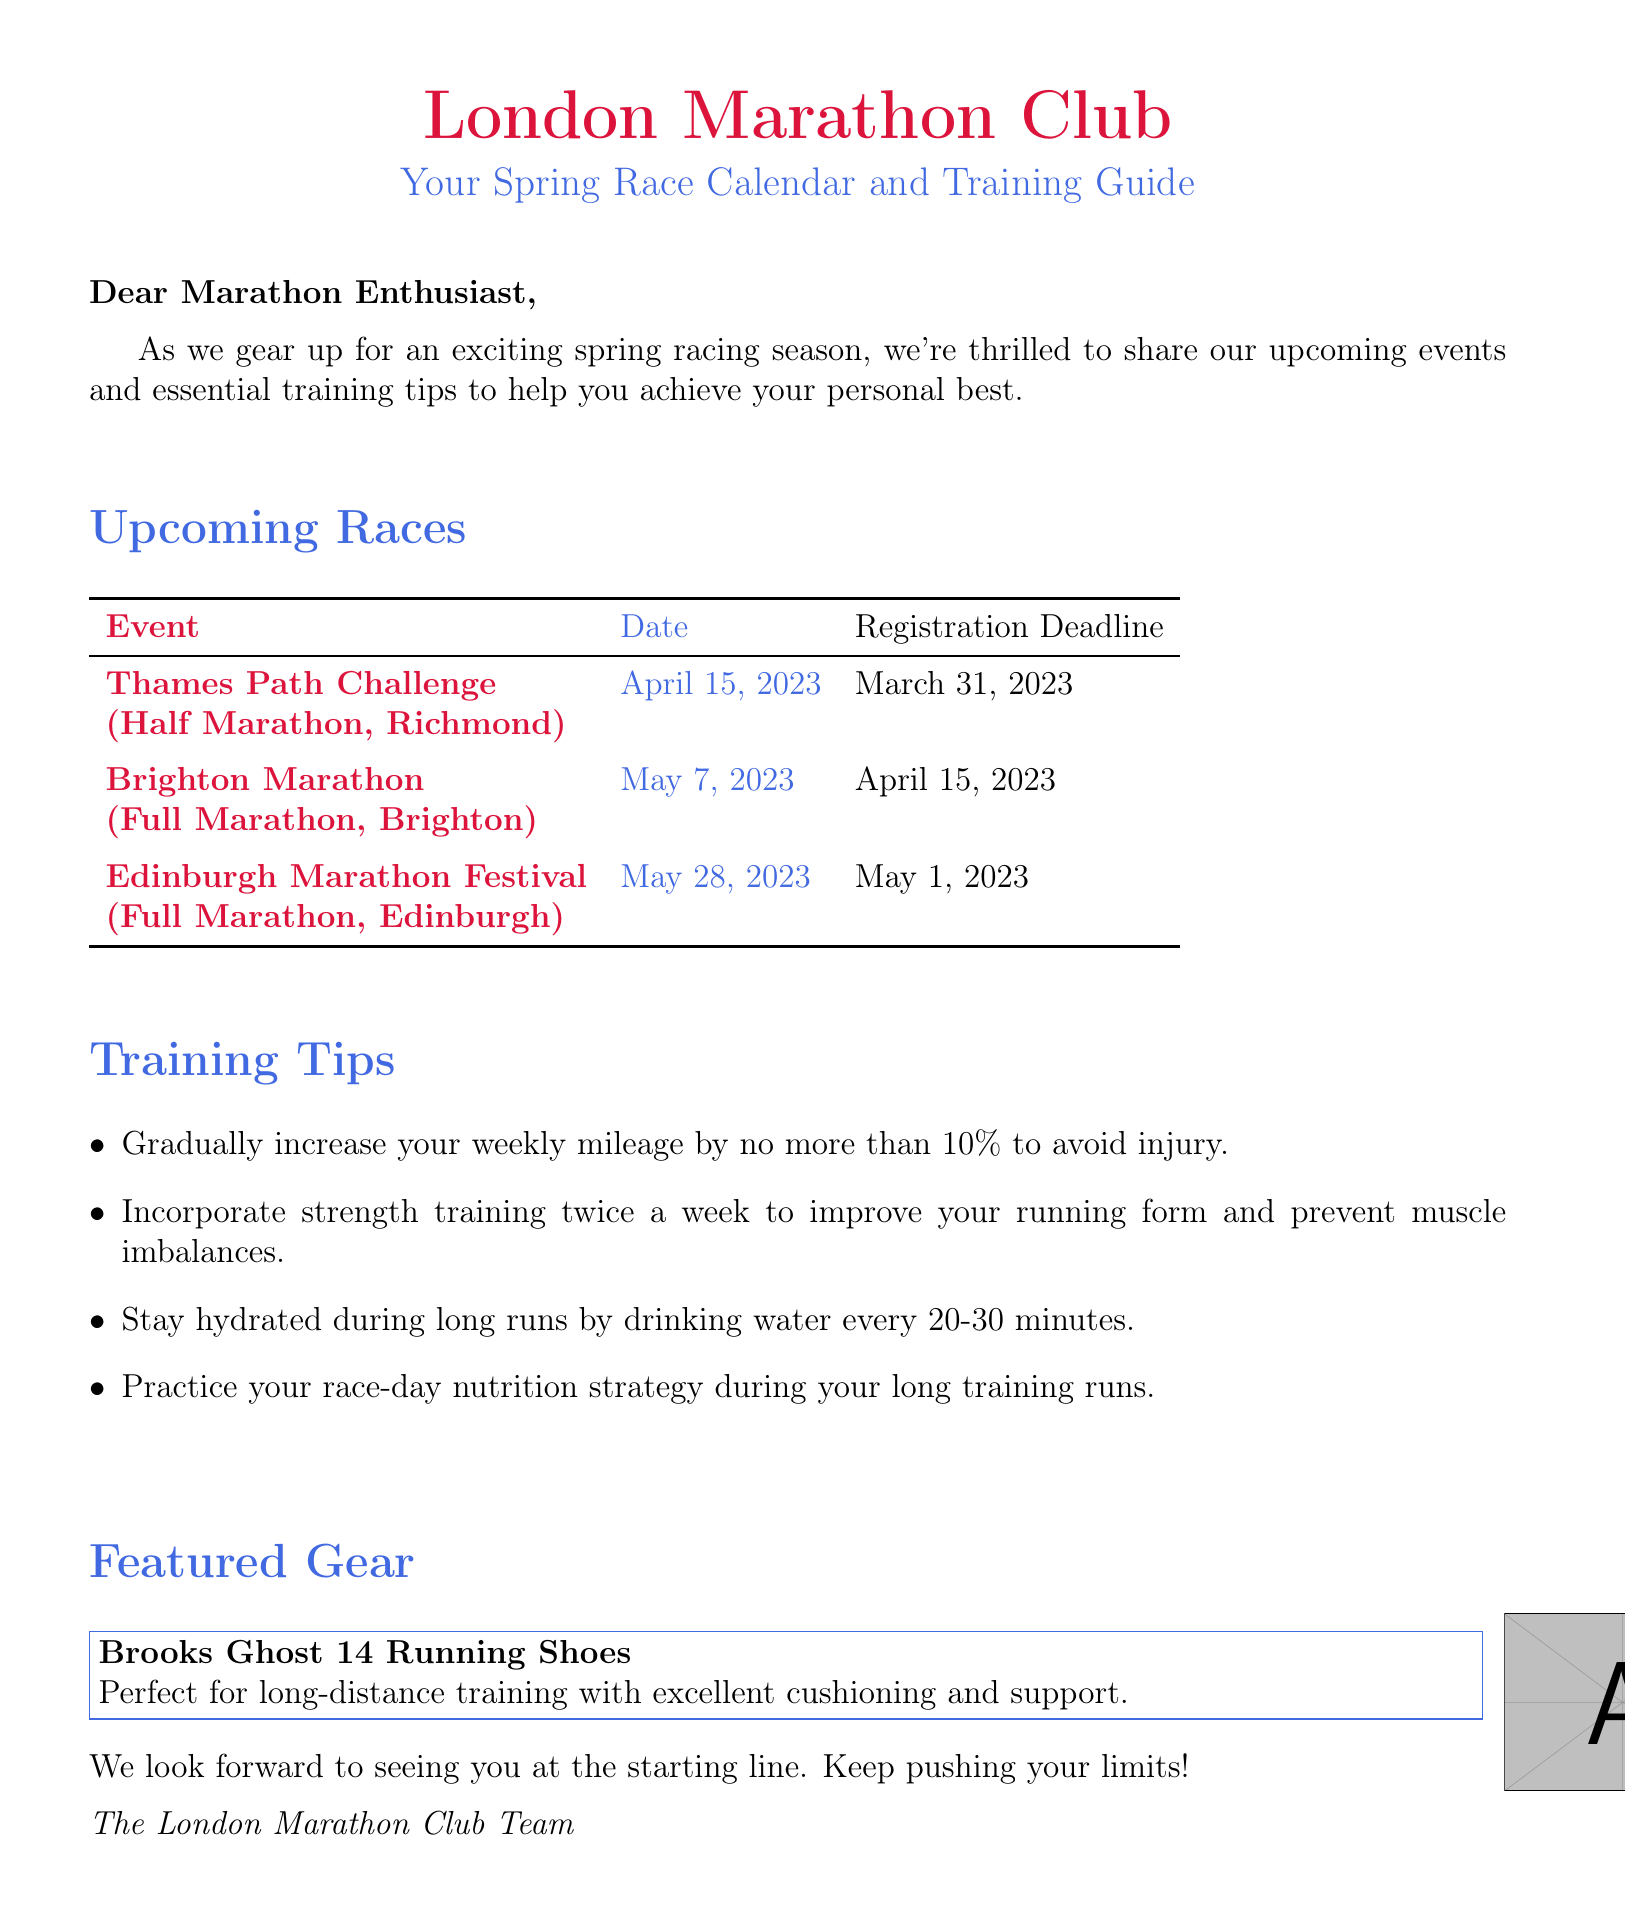what is the date of the Thames Path Challenge? The Thames Path Challenge is scheduled for April 15, 2023, as mentioned in the upcoming races section.
Answer: April 15, 2023 what is the distance of the Brighton Marathon? The Brighton Marathon is categorized as a Full Marathon, as indicated in the type of races section.
Answer: Full Marathon when is the registration deadline for the Edinburgh Marathon Festival? The registration deadline for the Edinburgh Marathon Festival is given as May 1, 2023.
Answer: May 1, 2023 what are the training tips provided in the email? The email lists several training tips, which include incremental mileage increases, strength training, hydration, and nutrition strategies during training.
Answer: Gradually increase weekly mileage, strength training, hydration, practice race-day nutrition which gear is featured in the newsletter? The featured gear is the Brooks Ghost 14 Running Shoes, noted for their cushioning and support for long-distance training.
Answer: Brooks Ghost 14 Running Shoes why is it important to stay hydrated during long runs? Staying hydrated is essential to maintain performance and health during long runs, as emphasized in the training tips provided in the document.
Answer: To maintain performance and health how many races are listed in the newsletter? The newsletter includes a total of three upcoming races, as detailed in the races section.
Answer: Three who is the email signed off by? The email concludes with a signature from the London Marathon Club Team.
Answer: The London Marathon Club Team 